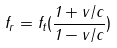<formula> <loc_0><loc_0><loc_500><loc_500>f _ { r } = f _ { t } ( \frac { 1 + v / c } { 1 - v / c } )</formula> 